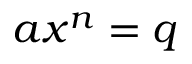Convert formula to latex. <formula><loc_0><loc_0><loc_500><loc_500>\ a x ^ { n } = q</formula> 